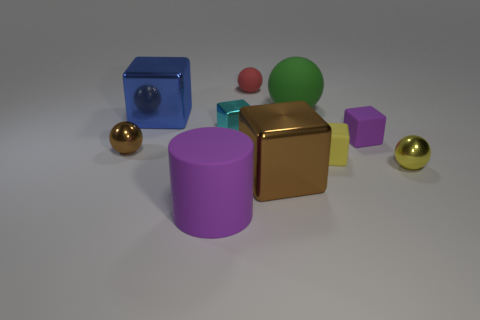Subtract all red matte balls. How many balls are left? 3 Subtract 1 cylinders. How many cylinders are left? 0 Subtract all brown blocks. How many blocks are left? 4 Subtract all cylinders. How many objects are left? 9 Add 1 small shiny things. How many small shiny things are left? 4 Add 7 tiny purple rubber cubes. How many tiny purple rubber cubes exist? 8 Subtract 0 red blocks. How many objects are left? 10 Subtract all gray balls. Subtract all yellow cylinders. How many balls are left? 4 Subtract all red cubes. How many brown balls are left? 1 Subtract all small brown cylinders. Subtract all small purple matte blocks. How many objects are left? 9 